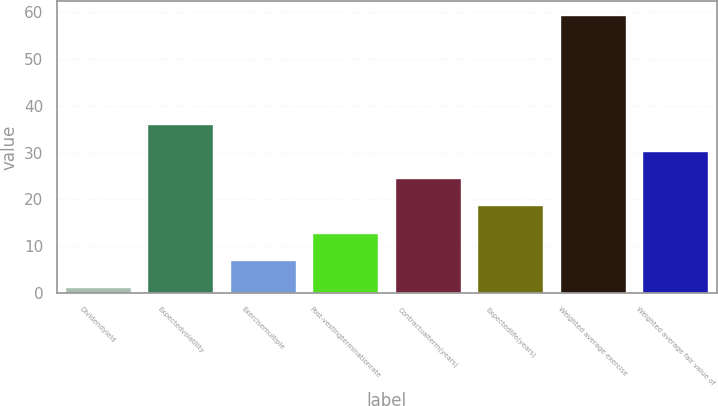Convert chart. <chart><loc_0><loc_0><loc_500><loc_500><bar_chart><fcel>Dividendyield<fcel>Expectedvolatility<fcel>Exercisemultiple<fcel>Post-vestingterminationrate<fcel>Contractualterm(years)<fcel>Expectedlife(years)<fcel>Weighted average exercise<fcel>Weighted average fair value of<nl><fcel>1.21<fcel>36.19<fcel>7.04<fcel>12.87<fcel>24.53<fcel>18.7<fcel>59.48<fcel>30.36<nl></chart> 